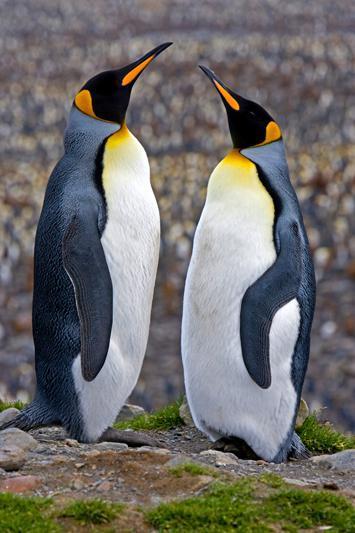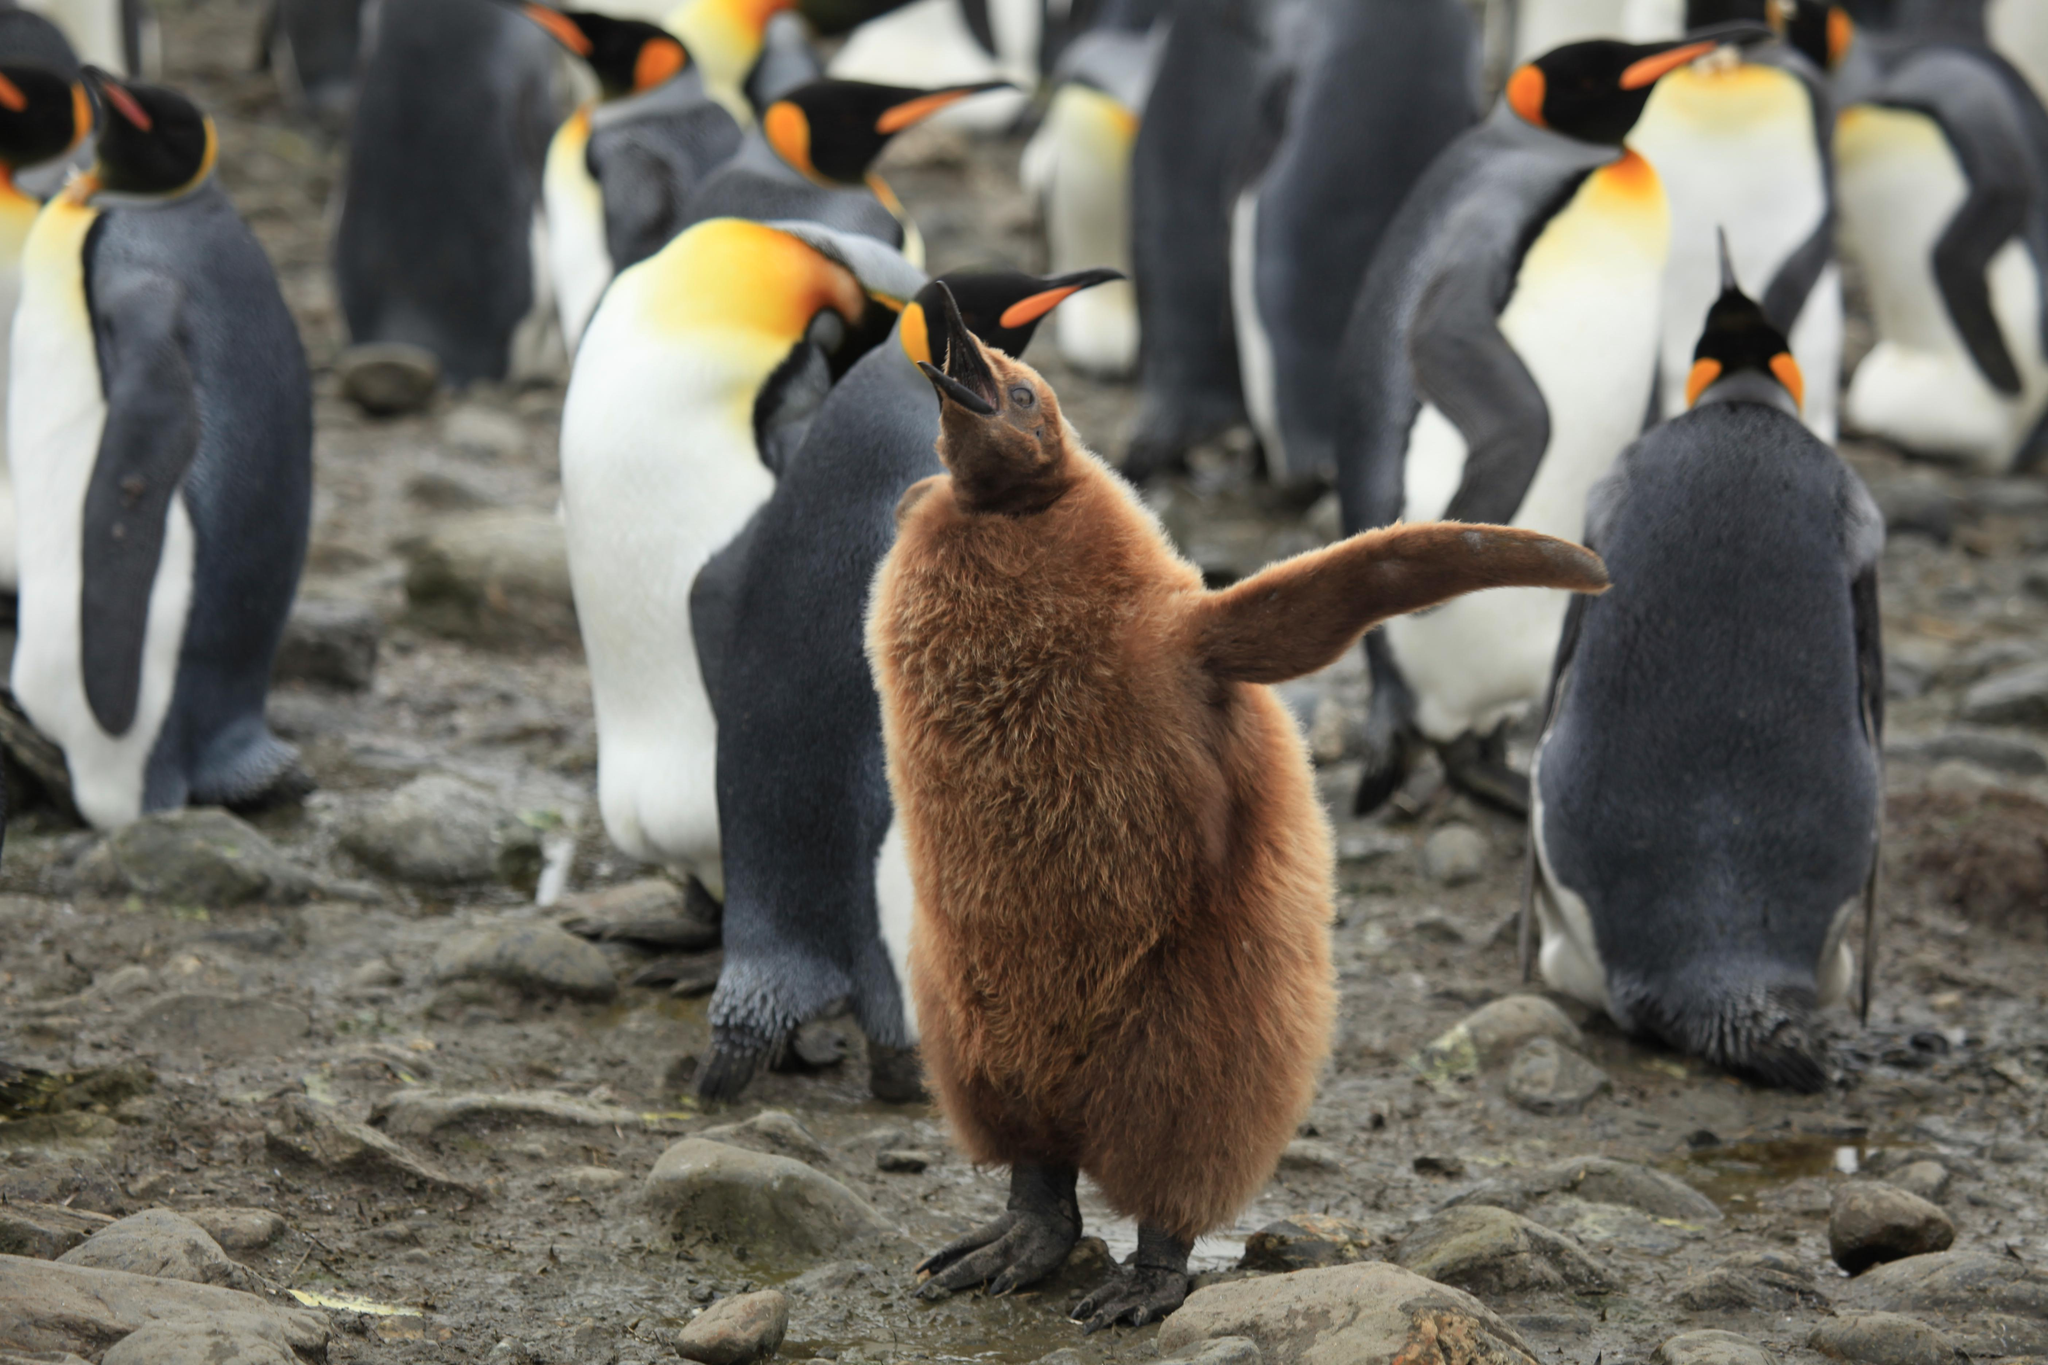The first image is the image on the left, the second image is the image on the right. For the images shown, is this caption "An image contains just two penguins." true? Answer yes or no. Yes. The first image is the image on the left, the second image is the image on the right. Examine the images to the left and right. Is the description "There are only two penguins in at least one of the images." accurate? Answer yes or no. Yes. The first image is the image on the left, the second image is the image on the right. Evaluate the accuracy of this statement regarding the images: "Two penguins stand near each other in the picture on the left.". Is it true? Answer yes or no. Yes. The first image is the image on the left, the second image is the image on the right. Considering the images on both sides, is "There are two penguins in the left image." valid? Answer yes or no. Yes. The first image is the image on the left, the second image is the image on the right. Assess this claim about the two images: "An image features two penguins standing close together.". Correct or not? Answer yes or no. Yes. 